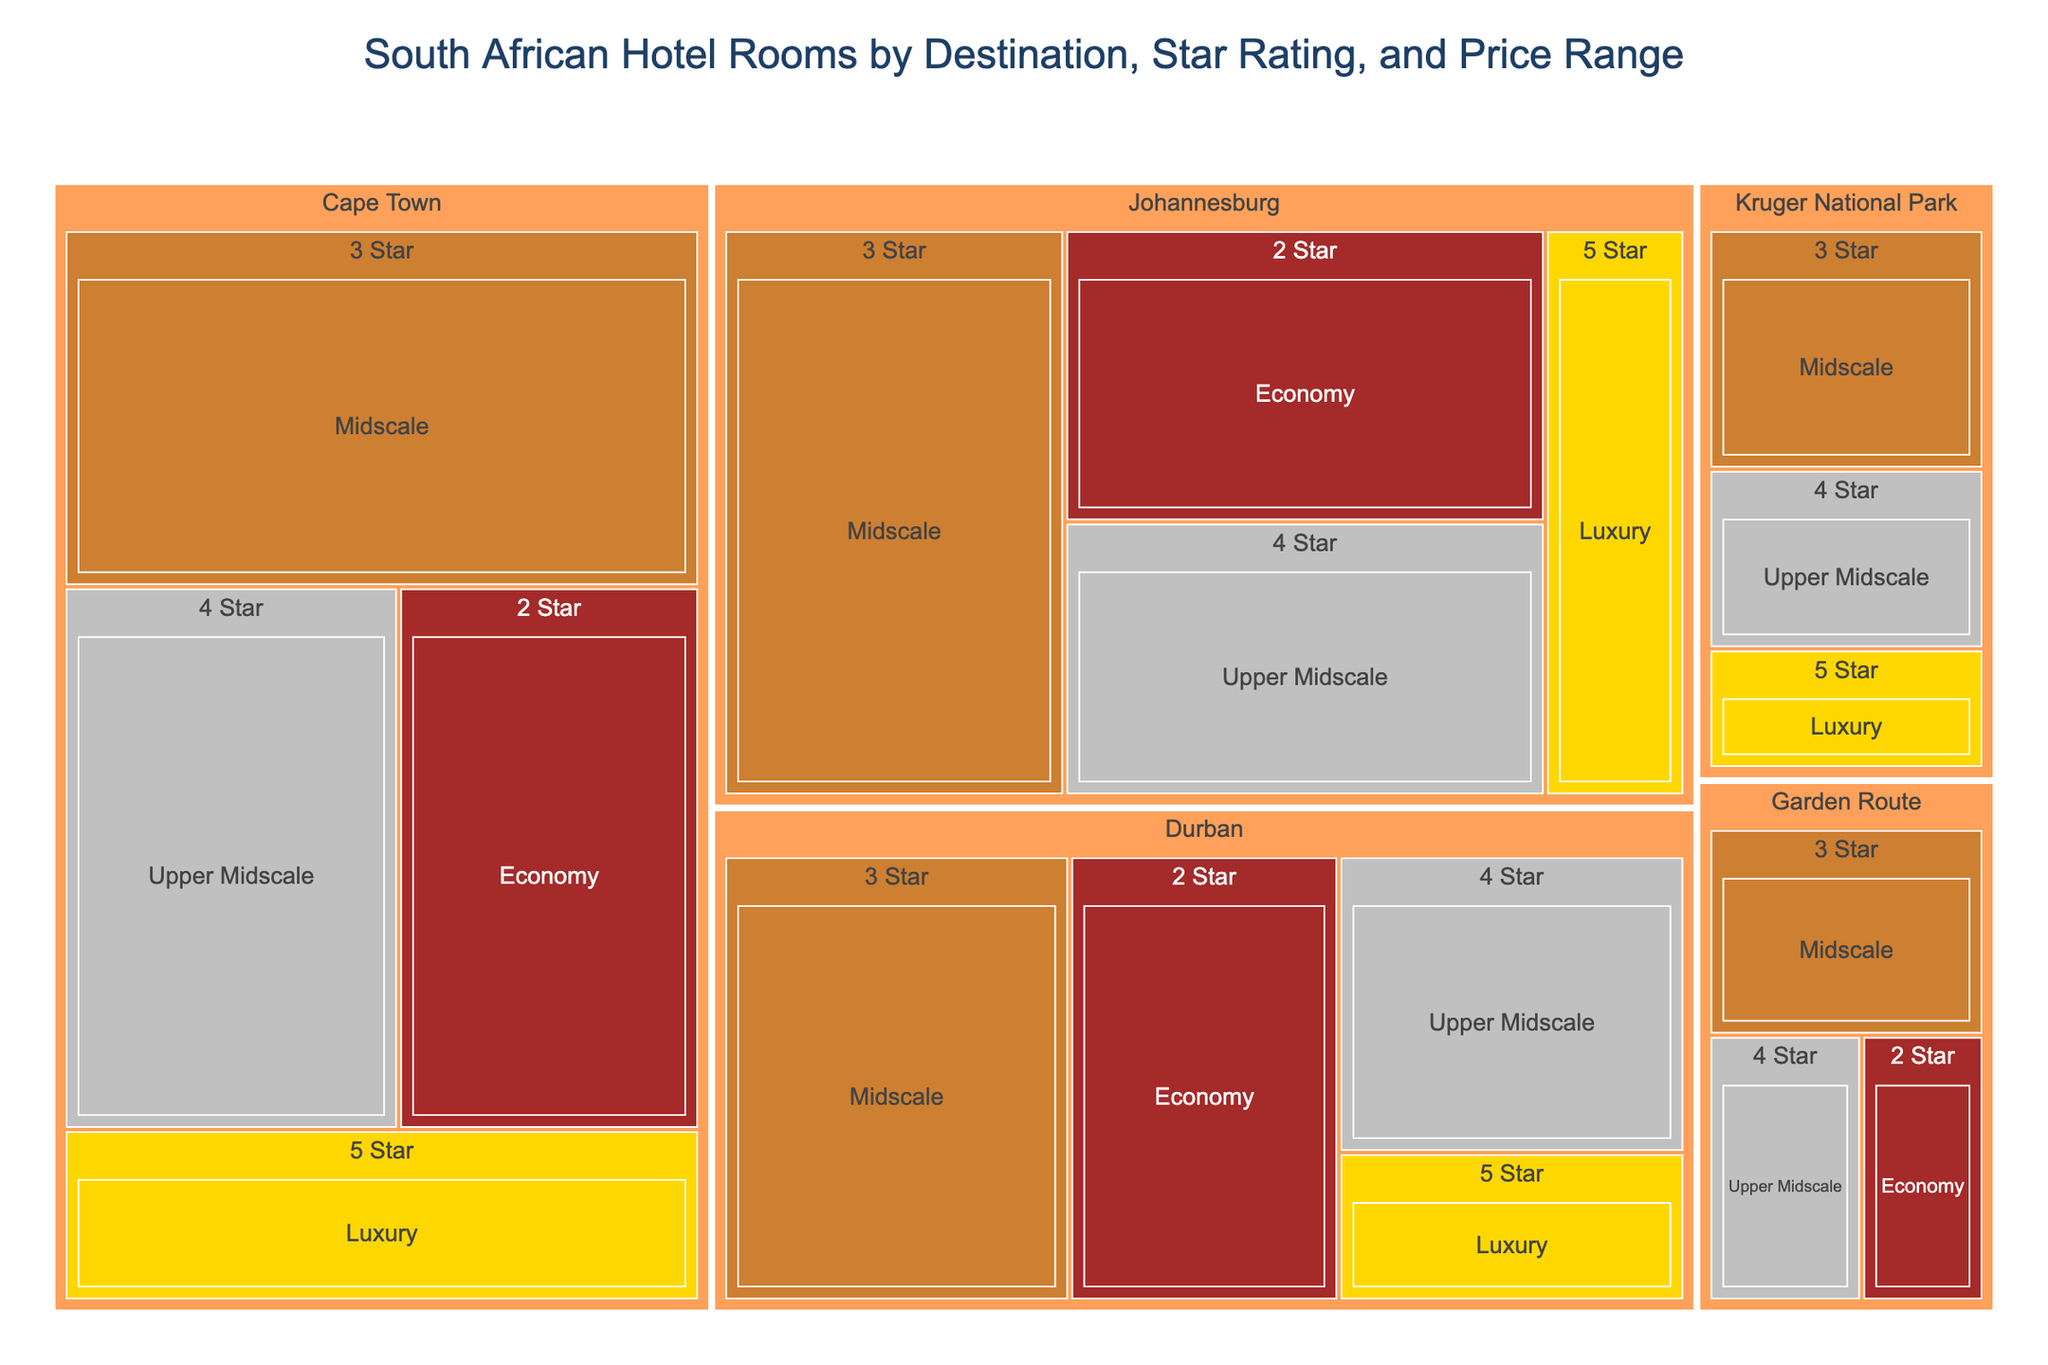What is the title of the treemap? The title is usually located at the top center of the plot.
Answer: South African Hotel Rooms by Destination, Star Rating, and Price Range Which destination has the highest number of 5-star hotel rooms? By identifying the size of the 5-star sections, Cape Town has the largest with 1200 rooms.
Answer: Cape Town How many rooms are there in Garden Route with a 4-star rating? Look at the section for Garden Route, then identify the 4-star rating segment and check the room count (500).
Answer: 500 Which price range has the highest number of rooms for Johannesburg? Compare the sizes of sections under Johannesburg, identifying which price range segment within each star rating has more rooms. Midscale (2200 rooms) has the highest count.
Answer: Midscale What is the total number of 3-star hotel rooms across all destinations? Sum the number of 3-star rooms from all destinations: Cape Town (2500) + Johannesburg (2200) + Durban (1800) + Kruger National Park (800) + Garden Route (700).
Answer: 8000 Between Durban and Kruger National Park, which one has more luxury (5-star) hotel rooms? Compare the sizes of 5-star sections for Durban (600) and Kruger National Park (400). Durban has more.
Answer: Durban What is the total number of rooms in Cape Town with economy price range? Identify the economy segment in Cape Town and check the room count (1800).
Answer: 1800 Which destination offers the smallest number of upper midscale (4-star) rooms? Compare the sizes of 4-star segments in each destination. Garden Route has the smallest with 500.
Answer: Garden Route Which two destinations have exactly the same number of rooms for a star rating? Identify segments with the same size across destinations. Durban and Johannesburg both have 1600 Economy rooms.
Answer: Durban and Johannesburg 